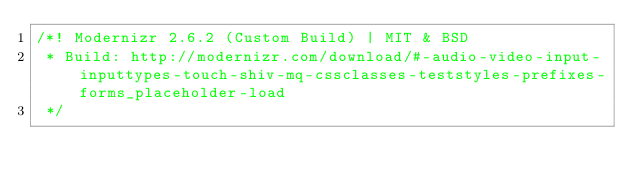<code> <loc_0><loc_0><loc_500><loc_500><_JavaScript_>/*! Modernizr 2.6.2 (Custom Build) | MIT & BSD
 * Build: http://modernizr.com/download/#-audio-video-input-inputtypes-touch-shiv-mq-cssclasses-teststyles-prefixes-forms_placeholder-load
 */</code> 